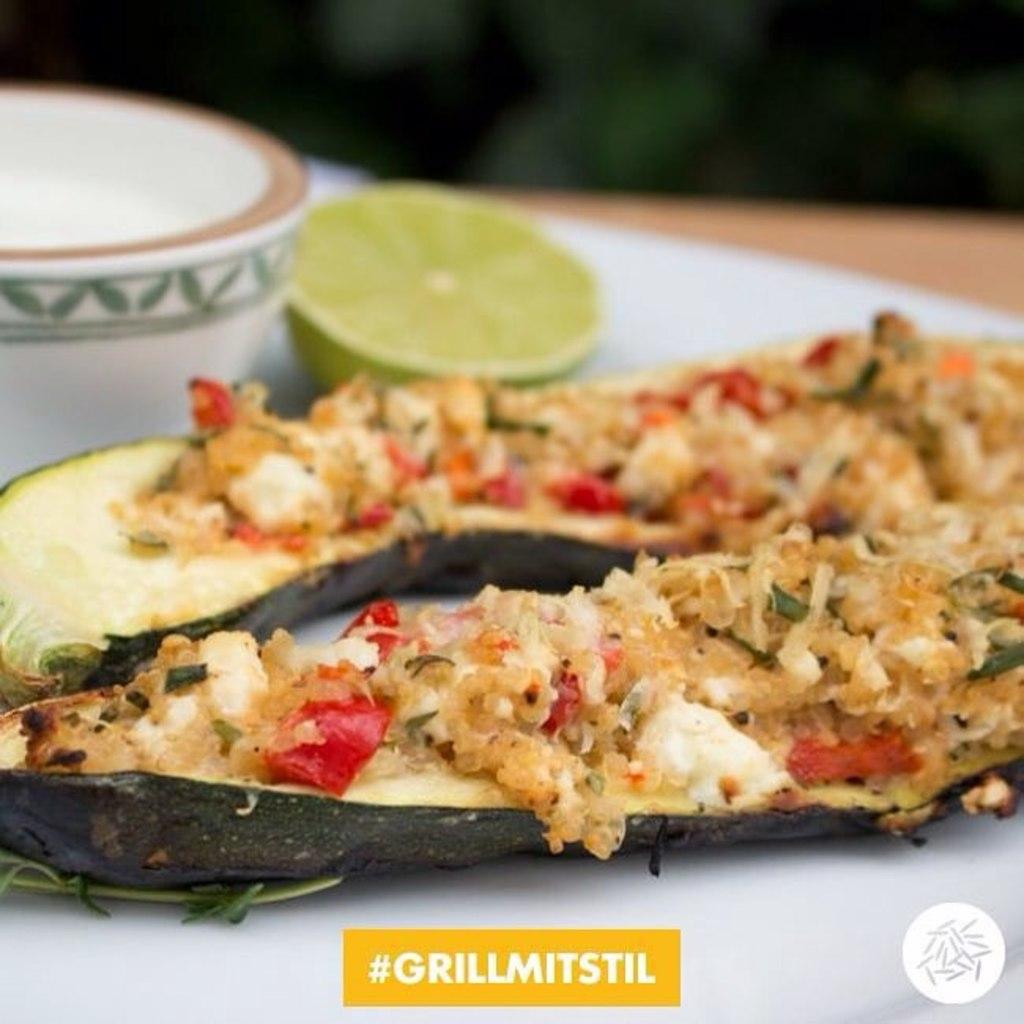What can be seen on the plate in the image? There are food items on a plate in the image. Can you identify any specific food item in the image? Yes, there is a piece of lemon in the image. What other container is visible in the image besides the plate? There is a bowl in the image. What type of bean is being used as a receipt in the image? There is no bean or receipt present in the image. 